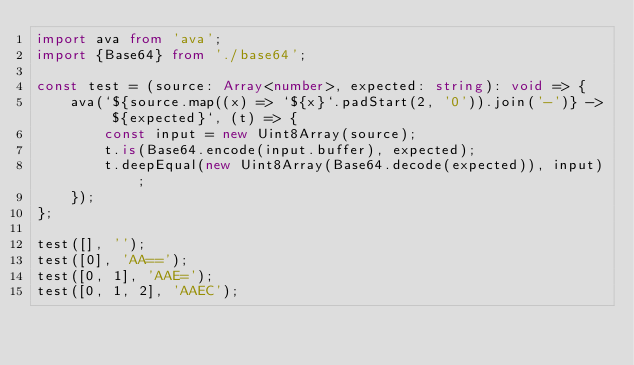<code> <loc_0><loc_0><loc_500><loc_500><_TypeScript_>import ava from 'ava';
import {Base64} from './base64';

const test = (source: Array<number>, expected: string): void => {
    ava(`${source.map((x) => `${x}`.padStart(2, '0')).join('-')} -> ${expected}`, (t) => {
        const input = new Uint8Array(source);
        t.is(Base64.encode(input.buffer), expected);
        t.deepEqual(new Uint8Array(Base64.decode(expected)), input);
    });
};

test([], '');
test([0], 'AA==');
test([0, 1], 'AAE=');
test([0, 1, 2], 'AAEC');
</code> 